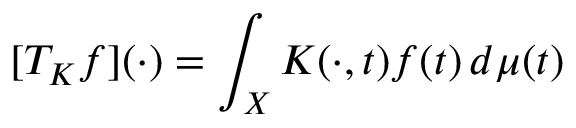<formula> <loc_0><loc_0><loc_500><loc_500>[ T _ { K } f ] ( \cdot ) = \int _ { X } K ( \cdot , t ) f ( t ) \, d \mu ( t )</formula> 